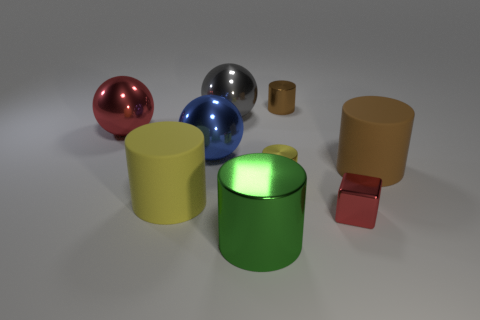Subtract all green cylinders. How many cylinders are left? 4 Subtract all large brown cylinders. How many cylinders are left? 4 Subtract all gray cylinders. Subtract all red blocks. How many cylinders are left? 5 Add 1 brown shiny balls. How many objects exist? 10 Subtract all blocks. How many objects are left? 8 Add 3 large yellow cylinders. How many large yellow cylinders exist? 4 Subtract 0 yellow spheres. How many objects are left? 9 Subtract all matte cylinders. Subtract all tiny yellow shiny things. How many objects are left? 6 Add 4 large gray shiny spheres. How many large gray shiny spheres are left? 5 